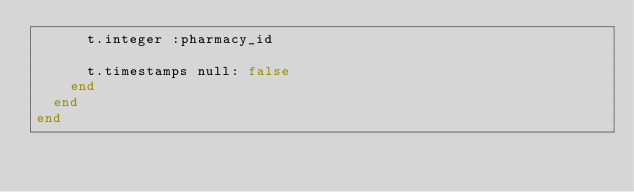Convert code to text. <code><loc_0><loc_0><loc_500><loc_500><_Ruby_>      t.integer :pharmacy_id

      t.timestamps null: false
    end
  end
end
</code> 